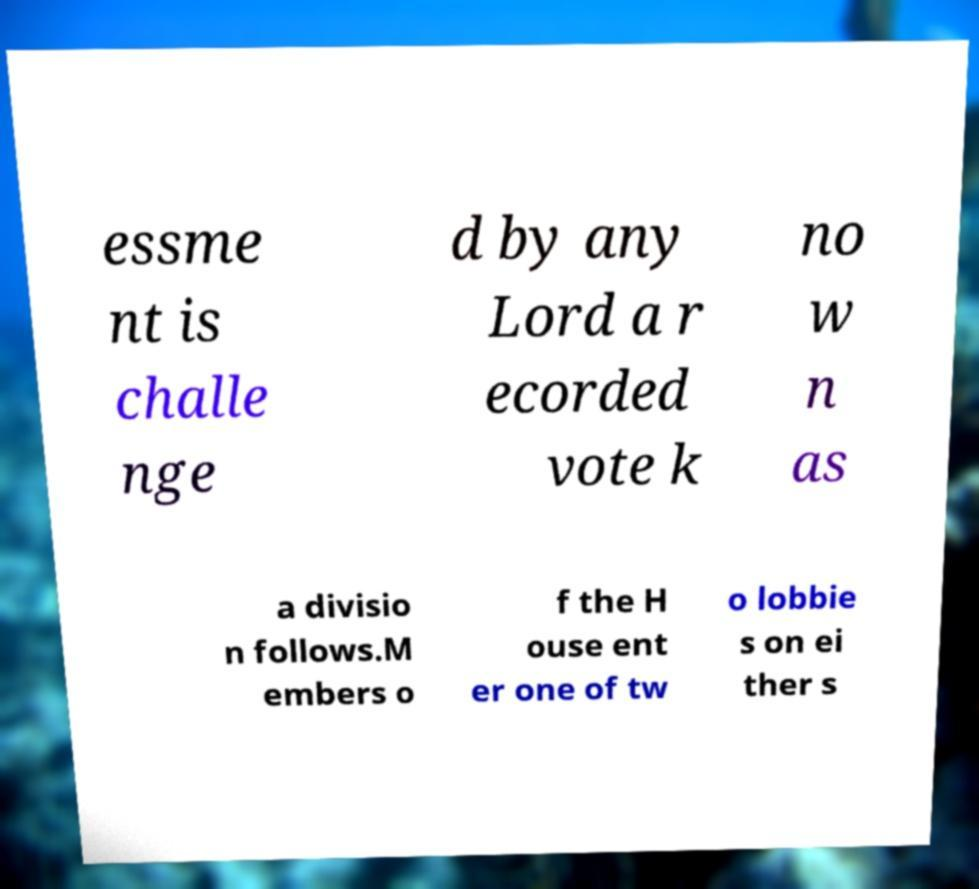Could you assist in decoding the text presented in this image and type it out clearly? essme nt is challe nge d by any Lord a r ecorded vote k no w n as a divisio n follows.M embers o f the H ouse ent er one of tw o lobbie s on ei ther s 